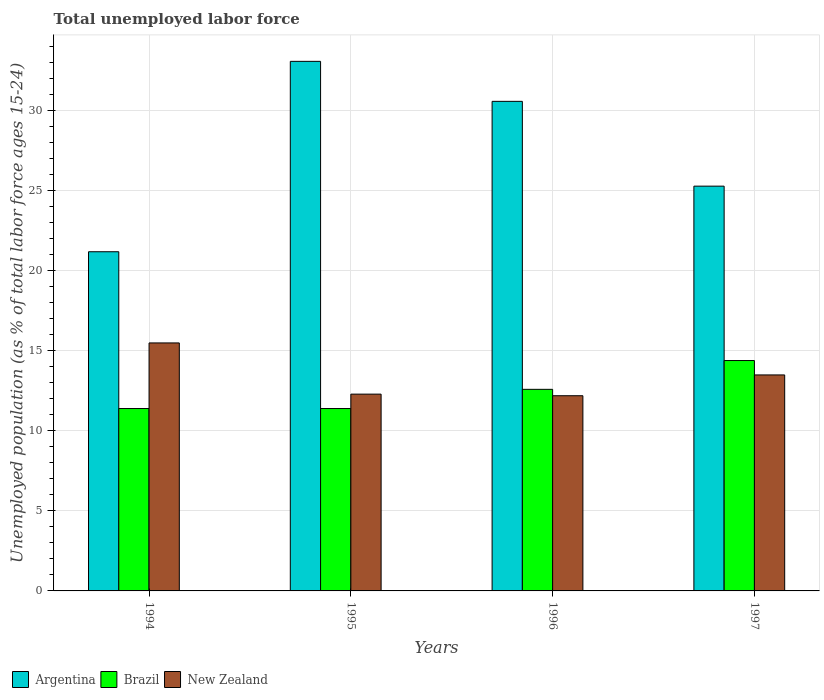How many different coloured bars are there?
Your answer should be very brief. 3. What is the label of the 1st group of bars from the left?
Provide a succinct answer. 1994. What is the percentage of unemployed population in in Argentina in 1995?
Provide a succinct answer. 33.1. Across all years, what is the maximum percentage of unemployed population in in Argentina?
Your response must be concise. 33.1. Across all years, what is the minimum percentage of unemployed population in in Argentina?
Your response must be concise. 21.2. In which year was the percentage of unemployed population in in Argentina maximum?
Your answer should be compact. 1995. In which year was the percentage of unemployed population in in Argentina minimum?
Ensure brevity in your answer.  1994. What is the total percentage of unemployed population in in New Zealand in the graph?
Give a very brief answer. 53.5. What is the difference between the percentage of unemployed population in in Brazil in 1994 and that in 1995?
Make the answer very short. 0. What is the difference between the percentage of unemployed population in in New Zealand in 1997 and the percentage of unemployed population in in Argentina in 1995?
Keep it short and to the point. -19.6. What is the average percentage of unemployed population in in Argentina per year?
Keep it short and to the point. 27.55. In the year 1994, what is the difference between the percentage of unemployed population in in Brazil and percentage of unemployed population in in Argentina?
Give a very brief answer. -9.8. What is the ratio of the percentage of unemployed population in in Argentina in 1994 to that in 1995?
Your response must be concise. 0.64. Is the percentage of unemployed population in in Brazil in 1994 less than that in 1995?
Ensure brevity in your answer.  No. Is the difference between the percentage of unemployed population in in Brazil in 1994 and 1995 greater than the difference between the percentage of unemployed population in in Argentina in 1994 and 1995?
Make the answer very short. Yes. In how many years, is the percentage of unemployed population in in Brazil greater than the average percentage of unemployed population in in Brazil taken over all years?
Offer a terse response. 2. What does the 3rd bar from the left in 1997 represents?
Your response must be concise. New Zealand. What is the difference between two consecutive major ticks on the Y-axis?
Ensure brevity in your answer.  5. Are the values on the major ticks of Y-axis written in scientific E-notation?
Offer a very short reply. No. Does the graph contain any zero values?
Your answer should be compact. No. Where does the legend appear in the graph?
Your answer should be very brief. Bottom left. What is the title of the graph?
Your answer should be very brief. Total unemployed labor force. What is the label or title of the Y-axis?
Ensure brevity in your answer.  Unemployed population (as % of total labor force ages 15-24). What is the Unemployed population (as % of total labor force ages 15-24) of Argentina in 1994?
Ensure brevity in your answer.  21.2. What is the Unemployed population (as % of total labor force ages 15-24) of Brazil in 1994?
Keep it short and to the point. 11.4. What is the Unemployed population (as % of total labor force ages 15-24) of Argentina in 1995?
Give a very brief answer. 33.1. What is the Unemployed population (as % of total labor force ages 15-24) of Brazil in 1995?
Your response must be concise. 11.4. What is the Unemployed population (as % of total labor force ages 15-24) in New Zealand in 1995?
Keep it short and to the point. 12.3. What is the Unemployed population (as % of total labor force ages 15-24) in Argentina in 1996?
Offer a very short reply. 30.6. What is the Unemployed population (as % of total labor force ages 15-24) of Brazil in 1996?
Give a very brief answer. 12.6. What is the Unemployed population (as % of total labor force ages 15-24) of New Zealand in 1996?
Offer a very short reply. 12.2. What is the Unemployed population (as % of total labor force ages 15-24) in Argentina in 1997?
Offer a terse response. 25.3. What is the Unemployed population (as % of total labor force ages 15-24) of Brazil in 1997?
Ensure brevity in your answer.  14.4. What is the Unemployed population (as % of total labor force ages 15-24) in New Zealand in 1997?
Make the answer very short. 13.5. Across all years, what is the maximum Unemployed population (as % of total labor force ages 15-24) of Argentina?
Make the answer very short. 33.1. Across all years, what is the maximum Unemployed population (as % of total labor force ages 15-24) of Brazil?
Offer a very short reply. 14.4. Across all years, what is the maximum Unemployed population (as % of total labor force ages 15-24) in New Zealand?
Your answer should be very brief. 15.5. Across all years, what is the minimum Unemployed population (as % of total labor force ages 15-24) of Argentina?
Ensure brevity in your answer.  21.2. Across all years, what is the minimum Unemployed population (as % of total labor force ages 15-24) in Brazil?
Provide a short and direct response. 11.4. Across all years, what is the minimum Unemployed population (as % of total labor force ages 15-24) in New Zealand?
Provide a short and direct response. 12.2. What is the total Unemployed population (as % of total labor force ages 15-24) of Argentina in the graph?
Give a very brief answer. 110.2. What is the total Unemployed population (as % of total labor force ages 15-24) in Brazil in the graph?
Offer a very short reply. 49.8. What is the total Unemployed population (as % of total labor force ages 15-24) of New Zealand in the graph?
Offer a terse response. 53.5. What is the difference between the Unemployed population (as % of total labor force ages 15-24) in Argentina in 1994 and that in 1995?
Keep it short and to the point. -11.9. What is the difference between the Unemployed population (as % of total labor force ages 15-24) in Argentina in 1994 and that in 1996?
Your response must be concise. -9.4. What is the difference between the Unemployed population (as % of total labor force ages 15-24) in Brazil in 1994 and that in 1996?
Offer a very short reply. -1.2. What is the difference between the Unemployed population (as % of total labor force ages 15-24) of New Zealand in 1994 and that in 1997?
Provide a succinct answer. 2. What is the difference between the Unemployed population (as % of total labor force ages 15-24) of Argentina in 1995 and that in 1996?
Your response must be concise. 2.5. What is the difference between the Unemployed population (as % of total labor force ages 15-24) in Brazil in 1995 and that in 1996?
Offer a very short reply. -1.2. What is the difference between the Unemployed population (as % of total labor force ages 15-24) in New Zealand in 1995 and that in 1996?
Provide a succinct answer. 0.1. What is the difference between the Unemployed population (as % of total labor force ages 15-24) in Brazil in 1996 and that in 1997?
Offer a very short reply. -1.8. What is the difference between the Unemployed population (as % of total labor force ages 15-24) in Argentina in 1994 and the Unemployed population (as % of total labor force ages 15-24) in Brazil in 1996?
Offer a terse response. 8.6. What is the difference between the Unemployed population (as % of total labor force ages 15-24) in Argentina in 1994 and the Unemployed population (as % of total labor force ages 15-24) in New Zealand in 1997?
Offer a very short reply. 7.7. What is the difference between the Unemployed population (as % of total labor force ages 15-24) in Argentina in 1995 and the Unemployed population (as % of total labor force ages 15-24) in Brazil in 1996?
Your answer should be compact. 20.5. What is the difference between the Unemployed population (as % of total labor force ages 15-24) of Argentina in 1995 and the Unemployed population (as % of total labor force ages 15-24) of New Zealand in 1996?
Keep it short and to the point. 20.9. What is the difference between the Unemployed population (as % of total labor force ages 15-24) of Argentina in 1995 and the Unemployed population (as % of total labor force ages 15-24) of Brazil in 1997?
Give a very brief answer. 18.7. What is the difference between the Unemployed population (as % of total labor force ages 15-24) of Argentina in 1995 and the Unemployed population (as % of total labor force ages 15-24) of New Zealand in 1997?
Make the answer very short. 19.6. What is the difference between the Unemployed population (as % of total labor force ages 15-24) in Brazil in 1995 and the Unemployed population (as % of total labor force ages 15-24) in New Zealand in 1997?
Your response must be concise. -2.1. What is the difference between the Unemployed population (as % of total labor force ages 15-24) of Argentina in 1996 and the Unemployed population (as % of total labor force ages 15-24) of Brazil in 1997?
Provide a succinct answer. 16.2. What is the average Unemployed population (as % of total labor force ages 15-24) in Argentina per year?
Your answer should be very brief. 27.55. What is the average Unemployed population (as % of total labor force ages 15-24) in Brazil per year?
Provide a succinct answer. 12.45. What is the average Unemployed population (as % of total labor force ages 15-24) of New Zealand per year?
Offer a very short reply. 13.38. In the year 1995, what is the difference between the Unemployed population (as % of total labor force ages 15-24) of Argentina and Unemployed population (as % of total labor force ages 15-24) of Brazil?
Your response must be concise. 21.7. In the year 1995, what is the difference between the Unemployed population (as % of total labor force ages 15-24) in Argentina and Unemployed population (as % of total labor force ages 15-24) in New Zealand?
Offer a terse response. 20.8. In the year 1995, what is the difference between the Unemployed population (as % of total labor force ages 15-24) of Brazil and Unemployed population (as % of total labor force ages 15-24) of New Zealand?
Provide a succinct answer. -0.9. In the year 1997, what is the difference between the Unemployed population (as % of total labor force ages 15-24) in Argentina and Unemployed population (as % of total labor force ages 15-24) in Brazil?
Provide a succinct answer. 10.9. What is the ratio of the Unemployed population (as % of total labor force ages 15-24) in Argentina in 1994 to that in 1995?
Give a very brief answer. 0.64. What is the ratio of the Unemployed population (as % of total labor force ages 15-24) of Brazil in 1994 to that in 1995?
Offer a very short reply. 1. What is the ratio of the Unemployed population (as % of total labor force ages 15-24) of New Zealand in 1994 to that in 1995?
Provide a short and direct response. 1.26. What is the ratio of the Unemployed population (as % of total labor force ages 15-24) of Argentina in 1994 to that in 1996?
Your answer should be very brief. 0.69. What is the ratio of the Unemployed population (as % of total labor force ages 15-24) of Brazil in 1994 to that in 1996?
Your answer should be very brief. 0.9. What is the ratio of the Unemployed population (as % of total labor force ages 15-24) of New Zealand in 1994 to that in 1996?
Ensure brevity in your answer.  1.27. What is the ratio of the Unemployed population (as % of total labor force ages 15-24) of Argentina in 1994 to that in 1997?
Your answer should be compact. 0.84. What is the ratio of the Unemployed population (as % of total labor force ages 15-24) of Brazil in 1994 to that in 1997?
Ensure brevity in your answer.  0.79. What is the ratio of the Unemployed population (as % of total labor force ages 15-24) in New Zealand in 1994 to that in 1997?
Keep it short and to the point. 1.15. What is the ratio of the Unemployed population (as % of total labor force ages 15-24) of Argentina in 1995 to that in 1996?
Your answer should be compact. 1.08. What is the ratio of the Unemployed population (as % of total labor force ages 15-24) of Brazil in 1995 to that in 1996?
Provide a succinct answer. 0.9. What is the ratio of the Unemployed population (as % of total labor force ages 15-24) in New Zealand in 1995 to that in 1996?
Your response must be concise. 1.01. What is the ratio of the Unemployed population (as % of total labor force ages 15-24) of Argentina in 1995 to that in 1997?
Ensure brevity in your answer.  1.31. What is the ratio of the Unemployed population (as % of total labor force ages 15-24) of Brazil in 1995 to that in 1997?
Offer a very short reply. 0.79. What is the ratio of the Unemployed population (as % of total labor force ages 15-24) in New Zealand in 1995 to that in 1997?
Your response must be concise. 0.91. What is the ratio of the Unemployed population (as % of total labor force ages 15-24) of Argentina in 1996 to that in 1997?
Offer a terse response. 1.21. What is the ratio of the Unemployed population (as % of total labor force ages 15-24) in New Zealand in 1996 to that in 1997?
Give a very brief answer. 0.9. What is the difference between the highest and the second highest Unemployed population (as % of total labor force ages 15-24) of Argentina?
Your answer should be compact. 2.5. What is the difference between the highest and the second highest Unemployed population (as % of total labor force ages 15-24) of Brazil?
Your answer should be compact. 1.8. What is the difference between the highest and the lowest Unemployed population (as % of total labor force ages 15-24) of Argentina?
Ensure brevity in your answer.  11.9. What is the difference between the highest and the lowest Unemployed population (as % of total labor force ages 15-24) of New Zealand?
Your answer should be very brief. 3.3. 